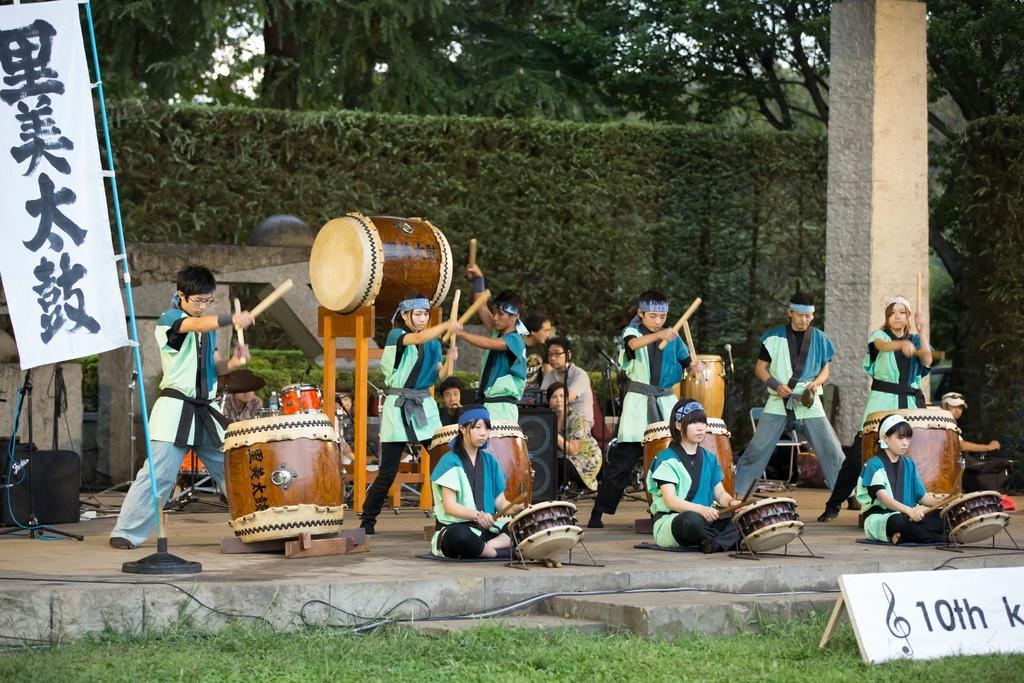Can you describe this image briefly? In this image there are group of persons who are beating the drums and at the background of the image there are trees and pole. 